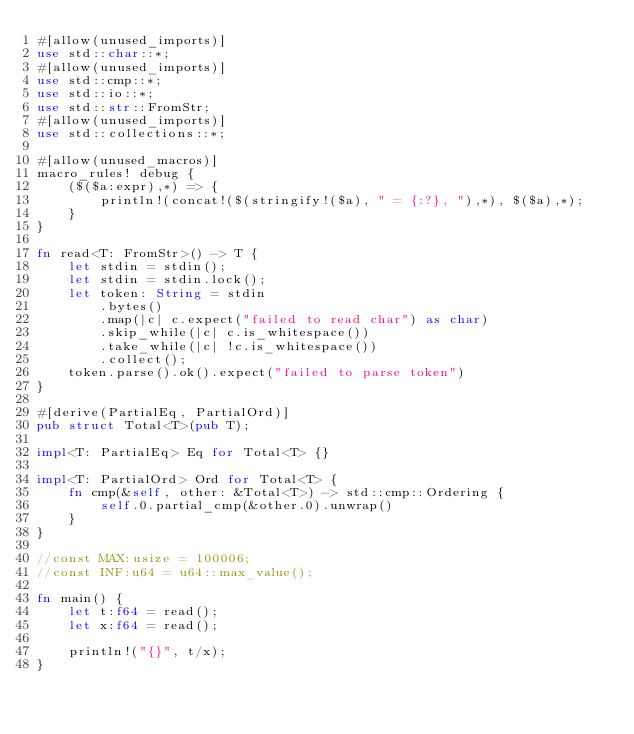Convert code to text. <code><loc_0><loc_0><loc_500><loc_500><_Rust_>#[allow(unused_imports)]
use std::char::*;
#[allow(unused_imports)]
use std::cmp::*;
use std::io::*;
use std::str::FromStr;
#[allow(unused_imports)]
use std::collections::*;

#[allow(unused_macros)]
macro_rules! debug {
    ($($a:expr),*) => {
        println!(concat!($(stringify!($a), " = {:?}, "),*), $($a),*);
    }
}

fn read<T: FromStr>() -> T {
    let stdin = stdin();
    let stdin = stdin.lock();
    let token: String = stdin
        .bytes()
        .map(|c| c.expect("failed to read char") as char)
        .skip_while(|c| c.is_whitespace())
        .take_while(|c| !c.is_whitespace())
        .collect();
    token.parse().ok().expect("failed to parse token")
}

#[derive(PartialEq, PartialOrd)]
pub struct Total<T>(pub T);

impl<T: PartialEq> Eq for Total<T> {}

impl<T: PartialOrd> Ord for Total<T> {
    fn cmp(&self, other: &Total<T>) -> std::cmp::Ordering {
        self.0.partial_cmp(&other.0).unwrap()
    }
}

//const MAX:usize = 100006;
//const INF:u64 = u64::max_value();

fn main() {
    let t:f64 = read();
    let x:f64 = read();

    println!("{}", t/x);
}
</code> 